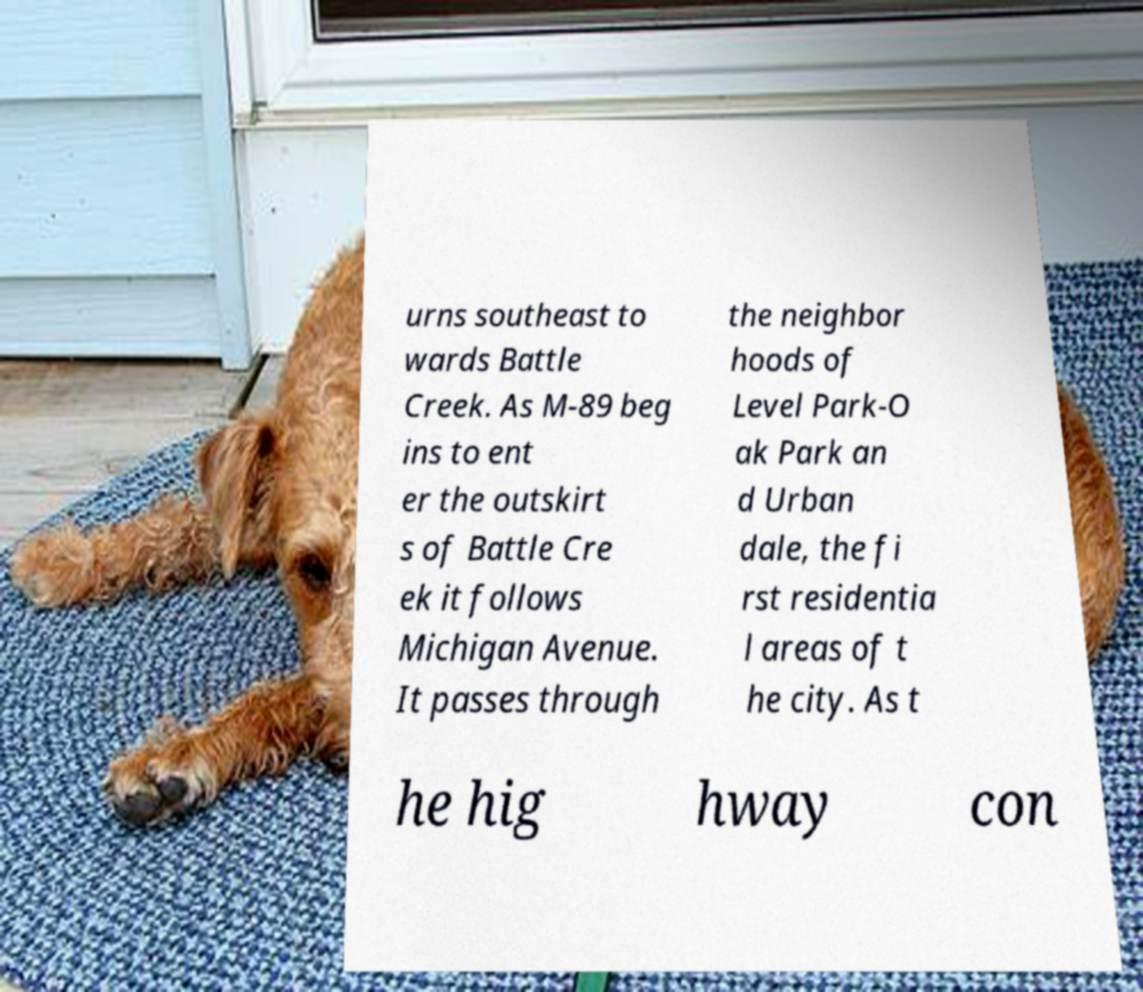Could you assist in decoding the text presented in this image and type it out clearly? urns southeast to wards Battle Creek. As M-89 beg ins to ent er the outskirt s of Battle Cre ek it follows Michigan Avenue. It passes through the neighbor hoods of Level Park-O ak Park an d Urban dale, the fi rst residentia l areas of t he city. As t he hig hway con 